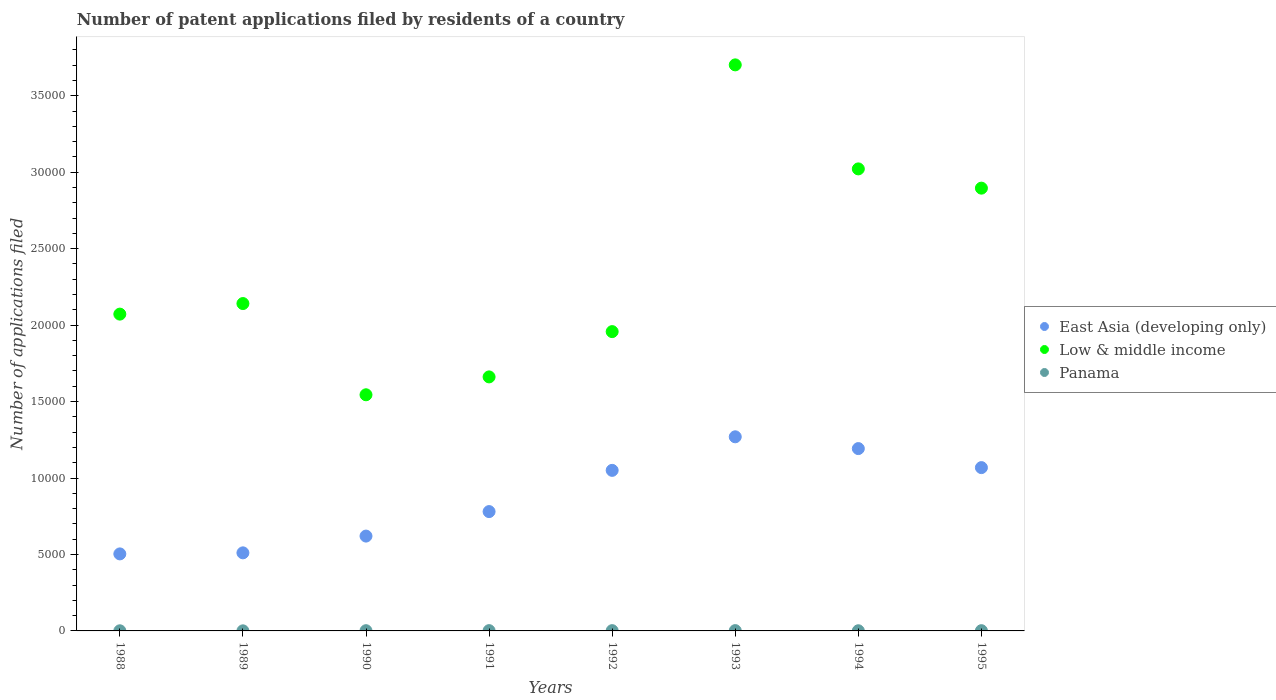What is the number of applications filed in Panama in 1991?
Offer a terse response. 19. Across all years, what is the maximum number of applications filed in Panama?
Offer a very short reply. 20. In which year was the number of applications filed in Panama minimum?
Give a very brief answer. 1989. What is the total number of applications filed in East Asia (developing only) in the graph?
Your answer should be very brief. 6.99e+04. What is the difference between the number of applications filed in East Asia (developing only) in 1988 and that in 1994?
Provide a succinct answer. -6887. What is the difference between the number of applications filed in Panama in 1992 and the number of applications filed in Low & middle income in 1989?
Offer a very short reply. -2.14e+04. What is the average number of applications filed in Low & middle income per year?
Provide a succinct answer. 2.37e+04. In the year 1992, what is the difference between the number of applications filed in East Asia (developing only) and number of applications filed in Low & middle income?
Give a very brief answer. -9074. In how many years, is the number of applications filed in Low & middle income greater than 21000?
Keep it short and to the point. 4. What is the ratio of the number of applications filed in Low & middle income in 1990 to that in 1993?
Your answer should be compact. 0.42. What is the difference between the highest and the lowest number of applications filed in Low & middle income?
Your response must be concise. 2.16e+04. Is the sum of the number of applications filed in Panama in 1988 and 1992 greater than the maximum number of applications filed in East Asia (developing only) across all years?
Provide a succinct answer. No. Is it the case that in every year, the sum of the number of applications filed in East Asia (developing only) and number of applications filed in Panama  is greater than the number of applications filed in Low & middle income?
Your answer should be very brief. No. Does the number of applications filed in East Asia (developing only) monotonically increase over the years?
Ensure brevity in your answer.  No. Is the number of applications filed in East Asia (developing only) strictly greater than the number of applications filed in Low & middle income over the years?
Offer a terse response. No. How many dotlines are there?
Your response must be concise. 3. What is the difference between two consecutive major ticks on the Y-axis?
Your answer should be very brief. 5000. Does the graph contain any zero values?
Provide a short and direct response. No. Does the graph contain grids?
Offer a very short reply. No. Where does the legend appear in the graph?
Keep it short and to the point. Center right. How are the legend labels stacked?
Give a very brief answer. Vertical. What is the title of the graph?
Give a very brief answer. Number of patent applications filed by residents of a country. What is the label or title of the Y-axis?
Your answer should be very brief. Number of applications filed. What is the Number of applications filed in East Asia (developing only) in 1988?
Give a very brief answer. 5037. What is the Number of applications filed of Low & middle income in 1988?
Offer a terse response. 2.07e+04. What is the Number of applications filed of Panama in 1988?
Keep it short and to the point. 9. What is the Number of applications filed of East Asia (developing only) in 1989?
Make the answer very short. 5106. What is the Number of applications filed in Low & middle income in 1989?
Offer a very short reply. 2.14e+04. What is the Number of applications filed of Panama in 1989?
Provide a succinct answer. 6. What is the Number of applications filed in East Asia (developing only) in 1990?
Provide a short and direct response. 6202. What is the Number of applications filed in Low & middle income in 1990?
Give a very brief answer. 1.54e+04. What is the Number of applications filed of Panama in 1990?
Your answer should be very brief. 15. What is the Number of applications filed of East Asia (developing only) in 1991?
Provide a succinct answer. 7804. What is the Number of applications filed in Low & middle income in 1991?
Make the answer very short. 1.66e+04. What is the Number of applications filed in Panama in 1991?
Your answer should be very brief. 19. What is the Number of applications filed in East Asia (developing only) in 1992?
Your answer should be very brief. 1.05e+04. What is the Number of applications filed of Low & middle income in 1992?
Your answer should be compact. 1.96e+04. What is the Number of applications filed in Panama in 1992?
Your response must be concise. 18. What is the Number of applications filed in East Asia (developing only) in 1993?
Provide a succinct answer. 1.27e+04. What is the Number of applications filed in Low & middle income in 1993?
Give a very brief answer. 3.70e+04. What is the Number of applications filed in Panama in 1993?
Give a very brief answer. 20. What is the Number of applications filed of East Asia (developing only) in 1994?
Your answer should be compact. 1.19e+04. What is the Number of applications filed of Low & middle income in 1994?
Give a very brief answer. 3.02e+04. What is the Number of applications filed of East Asia (developing only) in 1995?
Keep it short and to the point. 1.07e+04. What is the Number of applications filed in Low & middle income in 1995?
Offer a very short reply. 2.90e+04. What is the Number of applications filed of Panama in 1995?
Your response must be concise. 16. Across all years, what is the maximum Number of applications filed of East Asia (developing only)?
Your answer should be very brief. 1.27e+04. Across all years, what is the maximum Number of applications filed in Low & middle income?
Your answer should be very brief. 3.70e+04. Across all years, what is the maximum Number of applications filed in Panama?
Offer a very short reply. 20. Across all years, what is the minimum Number of applications filed of East Asia (developing only)?
Ensure brevity in your answer.  5037. Across all years, what is the minimum Number of applications filed in Low & middle income?
Offer a terse response. 1.54e+04. What is the total Number of applications filed of East Asia (developing only) in the graph?
Provide a short and direct response. 6.99e+04. What is the total Number of applications filed of Low & middle income in the graph?
Provide a short and direct response. 1.90e+05. What is the total Number of applications filed of Panama in the graph?
Provide a short and direct response. 114. What is the difference between the Number of applications filed of East Asia (developing only) in 1988 and that in 1989?
Offer a very short reply. -69. What is the difference between the Number of applications filed in Low & middle income in 1988 and that in 1989?
Provide a short and direct response. -691. What is the difference between the Number of applications filed of Panama in 1988 and that in 1989?
Keep it short and to the point. 3. What is the difference between the Number of applications filed in East Asia (developing only) in 1988 and that in 1990?
Offer a terse response. -1165. What is the difference between the Number of applications filed in Low & middle income in 1988 and that in 1990?
Your response must be concise. 5275. What is the difference between the Number of applications filed of Panama in 1988 and that in 1990?
Your answer should be compact. -6. What is the difference between the Number of applications filed in East Asia (developing only) in 1988 and that in 1991?
Give a very brief answer. -2767. What is the difference between the Number of applications filed in Low & middle income in 1988 and that in 1991?
Your response must be concise. 4106. What is the difference between the Number of applications filed in Panama in 1988 and that in 1991?
Offer a terse response. -10. What is the difference between the Number of applications filed in East Asia (developing only) in 1988 and that in 1992?
Your answer should be compact. -5463. What is the difference between the Number of applications filed in Low & middle income in 1988 and that in 1992?
Make the answer very short. 1144. What is the difference between the Number of applications filed in Panama in 1988 and that in 1992?
Your answer should be compact. -9. What is the difference between the Number of applications filed of East Asia (developing only) in 1988 and that in 1993?
Provide a short and direct response. -7658. What is the difference between the Number of applications filed in Low & middle income in 1988 and that in 1993?
Your answer should be compact. -1.63e+04. What is the difference between the Number of applications filed of Panama in 1988 and that in 1993?
Your response must be concise. -11. What is the difference between the Number of applications filed of East Asia (developing only) in 1988 and that in 1994?
Offer a terse response. -6887. What is the difference between the Number of applications filed of Low & middle income in 1988 and that in 1994?
Ensure brevity in your answer.  -9497. What is the difference between the Number of applications filed in Panama in 1988 and that in 1994?
Provide a short and direct response. -2. What is the difference between the Number of applications filed in East Asia (developing only) in 1988 and that in 1995?
Your response must be concise. -5643. What is the difference between the Number of applications filed of Low & middle income in 1988 and that in 1995?
Provide a short and direct response. -8238. What is the difference between the Number of applications filed in Panama in 1988 and that in 1995?
Your answer should be compact. -7. What is the difference between the Number of applications filed of East Asia (developing only) in 1989 and that in 1990?
Offer a terse response. -1096. What is the difference between the Number of applications filed of Low & middle income in 1989 and that in 1990?
Offer a very short reply. 5966. What is the difference between the Number of applications filed of East Asia (developing only) in 1989 and that in 1991?
Make the answer very short. -2698. What is the difference between the Number of applications filed in Low & middle income in 1989 and that in 1991?
Provide a succinct answer. 4797. What is the difference between the Number of applications filed in Panama in 1989 and that in 1991?
Your answer should be very brief. -13. What is the difference between the Number of applications filed in East Asia (developing only) in 1989 and that in 1992?
Give a very brief answer. -5394. What is the difference between the Number of applications filed of Low & middle income in 1989 and that in 1992?
Your answer should be very brief. 1835. What is the difference between the Number of applications filed in East Asia (developing only) in 1989 and that in 1993?
Offer a very short reply. -7589. What is the difference between the Number of applications filed in Low & middle income in 1989 and that in 1993?
Your response must be concise. -1.56e+04. What is the difference between the Number of applications filed in Panama in 1989 and that in 1993?
Your answer should be compact. -14. What is the difference between the Number of applications filed in East Asia (developing only) in 1989 and that in 1994?
Offer a terse response. -6818. What is the difference between the Number of applications filed of Low & middle income in 1989 and that in 1994?
Offer a terse response. -8806. What is the difference between the Number of applications filed in Panama in 1989 and that in 1994?
Make the answer very short. -5. What is the difference between the Number of applications filed of East Asia (developing only) in 1989 and that in 1995?
Offer a terse response. -5574. What is the difference between the Number of applications filed in Low & middle income in 1989 and that in 1995?
Your answer should be compact. -7547. What is the difference between the Number of applications filed of Panama in 1989 and that in 1995?
Ensure brevity in your answer.  -10. What is the difference between the Number of applications filed in East Asia (developing only) in 1990 and that in 1991?
Give a very brief answer. -1602. What is the difference between the Number of applications filed of Low & middle income in 1990 and that in 1991?
Ensure brevity in your answer.  -1169. What is the difference between the Number of applications filed of East Asia (developing only) in 1990 and that in 1992?
Your response must be concise. -4298. What is the difference between the Number of applications filed of Low & middle income in 1990 and that in 1992?
Offer a terse response. -4131. What is the difference between the Number of applications filed of East Asia (developing only) in 1990 and that in 1993?
Give a very brief answer. -6493. What is the difference between the Number of applications filed in Low & middle income in 1990 and that in 1993?
Offer a very short reply. -2.16e+04. What is the difference between the Number of applications filed in East Asia (developing only) in 1990 and that in 1994?
Provide a succinct answer. -5722. What is the difference between the Number of applications filed in Low & middle income in 1990 and that in 1994?
Keep it short and to the point. -1.48e+04. What is the difference between the Number of applications filed in East Asia (developing only) in 1990 and that in 1995?
Offer a terse response. -4478. What is the difference between the Number of applications filed of Low & middle income in 1990 and that in 1995?
Your answer should be compact. -1.35e+04. What is the difference between the Number of applications filed of Panama in 1990 and that in 1995?
Offer a terse response. -1. What is the difference between the Number of applications filed in East Asia (developing only) in 1991 and that in 1992?
Make the answer very short. -2696. What is the difference between the Number of applications filed in Low & middle income in 1991 and that in 1992?
Keep it short and to the point. -2962. What is the difference between the Number of applications filed in Panama in 1991 and that in 1992?
Your answer should be very brief. 1. What is the difference between the Number of applications filed of East Asia (developing only) in 1991 and that in 1993?
Provide a short and direct response. -4891. What is the difference between the Number of applications filed of Low & middle income in 1991 and that in 1993?
Offer a terse response. -2.04e+04. What is the difference between the Number of applications filed in East Asia (developing only) in 1991 and that in 1994?
Your response must be concise. -4120. What is the difference between the Number of applications filed in Low & middle income in 1991 and that in 1994?
Provide a short and direct response. -1.36e+04. What is the difference between the Number of applications filed in East Asia (developing only) in 1991 and that in 1995?
Keep it short and to the point. -2876. What is the difference between the Number of applications filed of Low & middle income in 1991 and that in 1995?
Provide a short and direct response. -1.23e+04. What is the difference between the Number of applications filed of East Asia (developing only) in 1992 and that in 1993?
Your answer should be very brief. -2195. What is the difference between the Number of applications filed in Low & middle income in 1992 and that in 1993?
Make the answer very short. -1.74e+04. What is the difference between the Number of applications filed of Panama in 1992 and that in 1993?
Give a very brief answer. -2. What is the difference between the Number of applications filed in East Asia (developing only) in 1992 and that in 1994?
Provide a succinct answer. -1424. What is the difference between the Number of applications filed of Low & middle income in 1992 and that in 1994?
Ensure brevity in your answer.  -1.06e+04. What is the difference between the Number of applications filed in Panama in 1992 and that in 1994?
Provide a short and direct response. 7. What is the difference between the Number of applications filed in East Asia (developing only) in 1992 and that in 1995?
Make the answer very short. -180. What is the difference between the Number of applications filed of Low & middle income in 1992 and that in 1995?
Provide a succinct answer. -9382. What is the difference between the Number of applications filed of Panama in 1992 and that in 1995?
Provide a short and direct response. 2. What is the difference between the Number of applications filed in East Asia (developing only) in 1993 and that in 1994?
Ensure brevity in your answer.  771. What is the difference between the Number of applications filed of Low & middle income in 1993 and that in 1994?
Make the answer very short. 6803. What is the difference between the Number of applications filed of East Asia (developing only) in 1993 and that in 1995?
Make the answer very short. 2015. What is the difference between the Number of applications filed of Low & middle income in 1993 and that in 1995?
Ensure brevity in your answer.  8062. What is the difference between the Number of applications filed in East Asia (developing only) in 1994 and that in 1995?
Offer a very short reply. 1244. What is the difference between the Number of applications filed of Low & middle income in 1994 and that in 1995?
Provide a succinct answer. 1259. What is the difference between the Number of applications filed of East Asia (developing only) in 1988 and the Number of applications filed of Low & middle income in 1989?
Offer a terse response. -1.64e+04. What is the difference between the Number of applications filed of East Asia (developing only) in 1988 and the Number of applications filed of Panama in 1989?
Provide a short and direct response. 5031. What is the difference between the Number of applications filed of Low & middle income in 1988 and the Number of applications filed of Panama in 1989?
Your answer should be compact. 2.07e+04. What is the difference between the Number of applications filed of East Asia (developing only) in 1988 and the Number of applications filed of Low & middle income in 1990?
Provide a succinct answer. -1.04e+04. What is the difference between the Number of applications filed in East Asia (developing only) in 1988 and the Number of applications filed in Panama in 1990?
Ensure brevity in your answer.  5022. What is the difference between the Number of applications filed in Low & middle income in 1988 and the Number of applications filed in Panama in 1990?
Your response must be concise. 2.07e+04. What is the difference between the Number of applications filed of East Asia (developing only) in 1988 and the Number of applications filed of Low & middle income in 1991?
Offer a terse response. -1.16e+04. What is the difference between the Number of applications filed in East Asia (developing only) in 1988 and the Number of applications filed in Panama in 1991?
Your response must be concise. 5018. What is the difference between the Number of applications filed in Low & middle income in 1988 and the Number of applications filed in Panama in 1991?
Offer a very short reply. 2.07e+04. What is the difference between the Number of applications filed in East Asia (developing only) in 1988 and the Number of applications filed in Low & middle income in 1992?
Offer a terse response. -1.45e+04. What is the difference between the Number of applications filed of East Asia (developing only) in 1988 and the Number of applications filed of Panama in 1992?
Ensure brevity in your answer.  5019. What is the difference between the Number of applications filed in Low & middle income in 1988 and the Number of applications filed in Panama in 1992?
Your answer should be very brief. 2.07e+04. What is the difference between the Number of applications filed of East Asia (developing only) in 1988 and the Number of applications filed of Low & middle income in 1993?
Your response must be concise. -3.20e+04. What is the difference between the Number of applications filed of East Asia (developing only) in 1988 and the Number of applications filed of Panama in 1993?
Offer a terse response. 5017. What is the difference between the Number of applications filed in Low & middle income in 1988 and the Number of applications filed in Panama in 1993?
Provide a succinct answer. 2.07e+04. What is the difference between the Number of applications filed of East Asia (developing only) in 1988 and the Number of applications filed of Low & middle income in 1994?
Your answer should be very brief. -2.52e+04. What is the difference between the Number of applications filed in East Asia (developing only) in 1988 and the Number of applications filed in Panama in 1994?
Keep it short and to the point. 5026. What is the difference between the Number of applications filed in Low & middle income in 1988 and the Number of applications filed in Panama in 1994?
Provide a succinct answer. 2.07e+04. What is the difference between the Number of applications filed in East Asia (developing only) in 1988 and the Number of applications filed in Low & middle income in 1995?
Provide a succinct answer. -2.39e+04. What is the difference between the Number of applications filed of East Asia (developing only) in 1988 and the Number of applications filed of Panama in 1995?
Provide a succinct answer. 5021. What is the difference between the Number of applications filed in Low & middle income in 1988 and the Number of applications filed in Panama in 1995?
Offer a terse response. 2.07e+04. What is the difference between the Number of applications filed of East Asia (developing only) in 1989 and the Number of applications filed of Low & middle income in 1990?
Offer a terse response. -1.03e+04. What is the difference between the Number of applications filed in East Asia (developing only) in 1989 and the Number of applications filed in Panama in 1990?
Offer a terse response. 5091. What is the difference between the Number of applications filed in Low & middle income in 1989 and the Number of applications filed in Panama in 1990?
Provide a succinct answer. 2.14e+04. What is the difference between the Number of applications filed of East Asia (developing only) in 1989 and the Number of applications filed of Low & middle income in 1991?
Ensure brevity in your answer.  -1.15e+04. What is the difference between the Number of applications filed in East Asia (developing only) in 1989 and the Number of applications filed in Panama in 1991?
Make the answer very short. 5087. What is the difference between the Number of applications filed of Low & middle income in 1989 and the Number of applications filed of Panama in 1991?
Offer a very short reply. 2.14e+04. What is the difference between the Number of applications filed in East Asia (developing only) in 1989 and the Number of applications filed in Low & middle income in 1992?
Your answer should be compact. -1.45e+04. What is the difference between the Number of applications filed of East Asia (developing only) in 1989 and the Number of applications filed of Panama in 1992?
Offer a very short reply. 5088. What is the difference between the Number of applications filed of Low & middle income in 1989 and the Number of applications filed of Panama in 1992?
Your answer should be compact. 2.14e+04. What is the difference between the Number of applications filed of East Asia (developing only) in 1989 and the Number of applications filed of Low & middle income in 1993?
Provide a succinct answer. -3.19e+04. What is the difference between the Number of applications filed of East Asia (developing only) in 1989 and the Number of applications filed of Panama in 1993?
Provide a succinct answer. 5086. What is the difference between the Number of applications filed of Low & middle income in 1989 and the Number of applications filed of Panama in 1993?
Give a very brief answer. 2.14e+04. What is the difference between the Number of applications filed in East Asia (developing only) in 1989 and the Number of applications filed in Low & middle income in 1994?
Offer a very short reply. -2.51e+04. What is the difference between the Number of applications filed of East Asia (developing only) in 1989 and the Number of applications filed of Panama in 1994?
Give a very brief answer. 5095. What is the difference between the Number of applications filed in Low & middle income in 1989 and the Number of applications filed in Panama in 1994?
Ensure brevity in your answer.  2.14e+04. What is the difference between the Number of applications filed in East Asia (developing only) in 1989 and the Number of applications filed in Low & middle income in 1995?
Offer a very short reply. -2.38e+04. What is the difference between the Number of applications filed in East Asia (developing only) in 1989 and the Number of applications filed in Panama in 1995?
Your answer should be very brief. 5090. What is the difference between the Number of applications filed in Low & middle income in 1989 and the Number of applications filed in Panama in 1995?
Your answer should be very brief. 2.14e+04. What is the difference between the Number of applications filed of East Asia (developing only) in 1990 and the Number of applications filed of Low & middle income in 1991?
Your response must be concise. -1.04e+04. What is the difference between the Number of applications filed in East Asia (developing only) in 1990 and the Number of applications filed in Panama in 1991?
Make the answer very short. 6183. What is the difference between the Number of applications filed in Low & middle income in 1990 and the Number of applications filed in Panama in 1991?
Offer a very short reply. 1.54e+04. What is the difference between the Number of applications filed of East Asia (developing only) in 1990 and the Number of applications filed of Low & middle income in 1992?
Your answer should be very brief. -1.34e+04. What is the difference between the Number of applications filed of East Asia (developing only) in 1990 and the Number of applications filed of Panama in 1992?
Offer a very short reply. 6184. What is the difference between the Number of applications filed in Low & middle income in 1990 and the Number of applications filed in Panama in 1992?
Your answer should be very brief. 1.54e+04. What is the difference between the Number of applications filed in East Asia (developing only) in 1990 and the Number of applications filed in Low & middle income in 1993?
Your answer should be compact. -3.08e+04. What is the difference between the Number of applications filed in East Asia (developing only) in 1990 and the Number of applications filed in Panama in 1993?
Your response must be concise. 6182. What is the difference between the Number of applications filed in Low & middle income in 1990 and the Number of applications filed in Panama in 1993?
Give a very brief answer. 1.54e+04. What is the difference between the Number of applications filed in East Asia (developing only) in 1990 and the Number of applications filed in Low & middle income in 1994?
Provide a short and direct response. -2.40e+04. What is the difference between the Number of applications filed in East Asia (developing only) in 1990 and the Number of applications filed in Panama in 1994?
Provide a succinct answer. 6191. What is the difference between the Number of applications filed of Low & middle income in 1990 and the Number of applications filed of Panama in 1994?
Offer a very short reply. 1.54e+04. What is the difference between the Number of applications filed of East Asia (developing only) in 1990 and the Number of applications filed of Low & middle income in 1995?
Keep it short and to the point. -2.28e+04. What is the difference between the Number of applications filed of East Asia (developing only) in 1990 and the Number of applications filed of Panama in 1995?
Give a very brief answer. 6186. What is the difference between the Number of applications filed of Low & middle income in 1990 and the Number of applications filed of Panama in 1995?
Ensure brevity in your answer.  1.54e+04. What is the difference between the Number of applications filed in East Asia (developing only) in 1991 and the Number of applications filed in Low & middle income in 1992?
Your answer should be compact. -1.18e+04. What is the difference between the Number of applications filed of East Asia (developing only) in 1991 and the Number of applications filed of Panama in 1992?
Ensure brevity in your answer.  7786. What is the difference between the Number of applications filed of Low & middle income in 1991 and the Number of applications filed of Panama in 1992?
Keep it short and to the point. 1.66e+04. What is the difference between the Number of applications filed of East Asia (developing only) in 1991 and the Number of applications filed of Low & middle income in 1993?
Your answer should be very brief. -2.92e+04. What is the difference between the Number of applications filed of East Asia (developing only) in 1991 and the Number of applications filed of Panama in 1993?
Offer a terse response. 7784. What is the difference between the Number of applications filed of Low & middle income in 1991 and the Number of applications filed of Panama in 1993?
Keep it short and to the point. 1.66e+04. What is the difference between the Number of applications filed in East Asia (developing only) in 1991 and the Number of applications filed in Low & middle income in 1994?
Your answer should be compact. -2.24e+04. What is the difference between the Number of applications filed in East Asia (developing only) in 1991 and the Number of applications filed in Panama in 1994?
Provide a succinct answer. 7793. What is the difference between the Number of applications filed of Low & middle income in 1991 and the Number of applications filed of Panama in 1994?
Keep it short and to the point. 1.66e+04. What is the difference between the Number of applications filed of East Asia (developing only) in 1991 and the Number of applications filed of Low & middle income in 1995?
Your answer should be very brief. -2.12e+04. What is the difference between the Number of applications filed of East Asia (developing only) in 1991 and the Number of applications filed of Panama in 1995?
Offer a terse response. 7788. What is the difference between the Number of applications filed in Low & middle income in 1991 and the Number of applications filed in Panama in 1995?
Offer a terse response. 1.66e+04. What is the difference between the Number of applications filed in East Asia (developing only) in 1992 and the Number of applications filed in Low & middle income in 1993?
Provide a succinct answer. -2.65e+04. What is the difference between the Number of applications filed in East Asia (developing only) in 1992 and the Number of applications filed in Panama in 1993?
Offer a terse response. 1.05e+04. What is the difference between the Number of applications filed of Low & middle income in 1992 and the Number of applications filed of Panama in 1993?
Offer a very short reply. 1.96e+04. What is the difference between the Number of applications filed in East Asia (developing only) in 1992 and the Number of applications filed in Low & middle income in 1994?
Make the answer very short. -1.97e+04. What is the difference between the Number of applications filed in East Asia (developing only) in 1992 and the Number of applications filed in Panama in 1994?
Keep it short and to the point. 1.05e+04. What is the difference between the Number of applications filed of Low & middle income in 1992 and the Number of applications filed of Panama in 1994?
Your response must be concise. 1.96e+04. What is the difference between the Number of applications filed of East Asia (developing only) in 1992 and the Number of applications filed of Low & middle income in 1995?
Keep it short and to the point. -1.85e+04. What is the difference between the Number of applications filed in East Asia (developing only) in 1992 and the Number of applications filed in Panama in 1995?
Your answer should be compact. 1.05e+04. What is the difference between the Number of applications filed of Low & middle income in 1992 and the Number of applications filed of Panama in 1995?
Ensure brevity in your answer.  1.96e+04. What is the difference between the Number of applications filed in East Asia (developing only) in 1993 and the Number of applications filed in Low & middle income in 1994?
Make the answer very short. -1.75e+04. What is the difference between the Number of applications filed in East Asia (developing only) in 1993 and the Number of applications filed in Panama in 1994?
Ensure brevity in your answer.  1.27e+04. What is the difference between the Number of applications filed in Low & middle income in 1993 and the Number of applications filed in Panama in 1994?
Your answer should be very brief. 3.70e+04. What is the difference between the Number of applications filed of East Asia (developing only) in 1993 and the Number of applications filed of Low & middle income in 1995?
Provide a succinct answer. -1.63e+04. What is the difference between the Number of applications filed in East Asia (developing only) in 1993 and the Number of applications filed in Panama in 1995?
Provide a short and direct response. 1.27e+04. What is the difference between the Number of applications filed of Low & middle income in 1993 and the Number of applications filed of Panama in 1995?
Give a very brief answer. 3.70e+04. What is the difference between the Number of applications filed in East Asia (developing only) in 1994 and the Number of applications filed in Low & middle income in 1995?
Offer a very short reply. -1.70e+04. What is the difference between the Number of applications filed of East Asia (developing only) in 1994 and the Number of applications filed of Panama in 1995?
Your answer should be compact. 1.19e+04. What is the difference between the Number of applications filed of Low & middle income in 1994 and the Number of applications filed of Panama in 1995?
Your response must be concise. 3.02e+04. What is the average Number of applications filed of East Asia (developing only) per year?
Provide a short and direct response. 8743.5. What is the average Number of applications filed of Low & middle income per year?
Provide a succinct answer. 2.37e+04. What is the average Number of applications filed of Panama per year?
Make the answer very short. 14.25. In the year 1988, what is the difference between the Number of applications filed in East Asia (developing only) and Number of applications filed in Low & middle income?
Provide a short and direct response. -1.57e+04. In the year 1988, what is the difference between the Number of applications filed in East Asia (developing only) and Number of applications filed in Panama?
Provide a succinct answer. 5028. In the year 1988, what is the difference between the Number of applications filed of Low & middle income and Number of applications filed of Panama?
Offer a terse response. 2.07e+04. In the year 1989, what is the difference between the Number of applications filed in East Asia (developing only) and Number of applications filed in Low & middle income?
Provide a succinct answer. -1.63e+04. In the year 1989, what is the difference between the Number of applications filed in East Asia (developing only) and Number of applications filed in Panama?
Keep it short and to the point. 5100. In the year 1989, what is the difference between the Number of applications filed of Low & middle income and Number of applications filed of Panama?
Provide a short and direct response. 2.14e+04. In the year 1990, what is the difference between the Number of applications filed of East Asia (developing only) and Number of applications filed of Low & middle income?
Provide a short and direct response. -9241. In the year 1990, what is the difference between the Number of applications filed of East Asia (developing only) and Number of applications filed of Panama?
Make the answer very short. 6187. In the year 1990, what is the difference between the Number of applications filed of Low & middle income and Number of applications filed of Panama?
Offer a terse response. 1.54e+04. In the year 1991, what is the difference between the Number of applications filed of East Asia (developing only) and Number of applications filed of Low & middle income?
Ensure brevity in your answer.  -8808. In the year 1991, what is the difference between the Number of applications filed in East Asia (developing only) and Number of applications filed in Panama?
Your answer should be compact. 7785. In the year 1991, what is the difference between the Number of applications filed of Low & middle income and Number of applications filed of Panama?
Provide a short and direct response. 1.66e+04. In the year 1992, what is the difference between the Number of applications filed of East Asia (developing only) and Number of applications filed of Low & middle income?
Ensure brevity in your answer.  -9074. In the year 1992, what is the difference between the Number of applications filed of East Asia (developing only) and Number of applications filed of Panama?
Your response must be concise. 1.05e+04. In the year 1992, what is the difference between the Number of applications filed in Low & middle income and Number of applications filed in Panama?
Ensure brevity in your answer.  1.96e+04. In the year 1993, what is the difference between the Number of applications filed of East Asia (developing only) and Number of applications filed of Low & middle income?
Your answer should be compact. -2.43e+04. In the year 1993, what is the difference between the Number of applications filed of East Asia (developing only) and Number of applications filed of Panama?
Provide a succinct answer. 1.27e+04. In the year 1993, what is the difference between the Number of applications filed of Low & middle income and Number of applications filed of Panama?
Your answer should be very brief. 3.70e+04. In the year 1994, what is the difference between the Number of applications filed of East Asia (developing only) and Number of applications filed of Low & middle income?
Make the answer very short. -1.83e+04. In the year 1994, what is the difference between the Number of applications filed in East Asia (developing only) and Number of applications filed in Panama?
Provide a short and direct response. 1.19e+04. In the year 1994, what is the difference between the Number of applications filed in Low & middle income and Number of applications filed in Panama?
Keep it short and to the point. 3.02e+04. In the year 1995, what is the difference between the Number of applications filed in East Asia (developing only) and Number of applications filed in Low & middle income?
Your answer should be compact. -1.83e+04. In the year 1995, what is the difference between the Number of applications filed of East Asia (developing only) and Number of applications filed of Panama?
Offer a very short reply. 1.07e+04. In the year 1995, what is the difference between the Number of applications filed of Low & middle income and Number of applications filed of Panama?
Your answer should be very brief. 2.89e+04. What is the ratio of the Number of applications filed of East Asia (developing only) in 1988 to that in 1989?
Provide a short and direct response. 0.99. What is the ratio of the Number of applications filed in Panama in 1988 to that in 1989?
Your answer should be very brief. 1.5. What is the ratio of the Number of applications filed in East Asia (developing only) in 1988 to that in 1990?
Give a very brief answer. 0.81. What is the ratio of the Number of applications filed of Low & middle income in 1988 to that in 1990?
Ensure brevity in your answer.  1.34. What is the ratio of the Number of applications filed of East Asia (developing only) in 1988 to that in 1991?
Your answer should be compact. 0.65. What is the ratio of the Number of applications filed in Low & middle income in 1988 to that in 1991?
Ensure brevity in your answer.  1.25. What is the ratio of the Number of applications filed in Panama in 1988 to that in 1991?
Your answer should be very brief. 0.47. What is the ratio of the Number of applications filed of East Asia (developing only) in 1988 to that in 1992?
Offer a very short reply. 0.48. What is the ratio of the Number of applications filed of Low & middle income in 1988 to that in 1992?
Make the answer very short. 1.06. What is the ratio of the Number of applications filed in Panama in 1988 to that in 1992?
Your response must be concise. 0.5. What is the ratio of the Number of applications filed in East Asia (developing only) in 1988 to that in 1993?
Your answer should be very brief. 0.4. What is the ratio of the Number of applications filed of Low & middle income in 1988 to that in 1993?
Ensure brevity in your answer.  0.56. What is the ratio of the Number of applications filed in Panama in 1988 to that in 1993?
Keep it short and to the point. 0.45. What is the ratio of the Number of applications filed in East Asia (developing only) in 1988 to that in 1994?
Offer a terse response. 0.42. What is the ratio of the Number of applications filed of Low & middle income in 1988 to that in 1994?
Your answer should be very brief. 0.69. What is the ratio of the Number of applications filed of Panama in 1988 to that in 1994?
Offer a terse response. 0.82. What is the ratio of the Number of applications filed in East Asia (developing only) in 1988 to that in 1995?
Your answer should be very brief. 0.47. What is the ratio of the Number of applications filed of Low & middle income in 1988 to that in 1995?
Offer a very short reply. 0.72. What is the ratio of the Number of applications filed of Panama in 1988 to that in 1995?
Your answer should be very brief. 0.56. What is the ratio of the Number of applications filed in East Asia (developing only) in 1989 to that in 1990?
Your response must be concise. 0.82. What is the ratio of the Number of applications filed of Low & middle income in 1989 to that in 1990?
Your answer should be very brief. 1.39. What is the ratio of the Number of applications filed in Panama in 1989 to that in 1990?
Your response must be concise. 0.4. What is the ratio of the Number of applications filed of East Asia (developing only) in 1989 to that in 1991?
Make the answer very short. 0.65. What is the ratio of the Number of applications filed in Low & middle income in 1989 to that in 1991?
Your response must be concise. 1.29. What is the ratio of the Number of applications filed in Panama in 1989 to that in 1991?
Offer a very short reply. 0.32. What is the ratio of the Number of applications filed of East Asia (developing only) in 1989 to that in 1992?
Your answer should be compact. 0.49. What is the ratio of the Number of applications filed in Low & middle income in 1989 to that in 1992?
Give a very brief answer. 1.09. What is the ratio of the Number of applications filed in East Asia (developing only) in 1989 to that in 1993?
Keep it short and to the point. 0.4. What is the ratio of the Number of applications filed of Low & middle income in 1989 to that in 1993?
Offer a terse response. 0.58. What is the ratio of the Number of applications filed of East Asia (developing only) in 1989 to that in 1994?
Your answer should be very brief. 0.43. What is the ratio of the Number of applications filed in Low & middle income in 1989 to that in 1994?
Your answer should be very brief. 0.71. What is the ratio of the Number of applications filed in Panama in 1989 to that in 1994?
Keep it short and to the point. 0.55. What is the ratio of the Number of applications filed in East Asia (developing only) in 1989 to that in 1995?
Keep it short and to the point. 0.48. What is the ratio of the Number of applications filed in Low & middle income in 1989 to that in 1995?
Provide a short and direct response. 0.74. What is the ratio of the Number of applications filed of Panama in 1989 to that in 1995?
Ensure brevity in your answer.  0.38. What is the ratio of the Number of applications filed of East Asia (developing only) in 1990 to that in 1991?
Ensure brevity in your answer.  0.79. What is the ratio of the Number of applications filed of Low & middle income in 1990 to that in 1991?
Your answer should be very brief. 0.93. What is the ratio of the Number of applications filed in Panama in 1990 to that in 1991?
Keep it short and to the point. 0.79. What is the ratio of the Number of applications filed in East Asia (developing only) in 1990 to that in 1992?
Provide a short and direct response. 0.59. What is the ratio of the Number of applications filed in Low & middle income in 1990 to that in 1992?
Offer a very short reply. 0.79. What is the ratio of the Number of applications filed in East Asia (developing only) in 1990 to that in 1993?
Ensure brevity in your answer.  0.49. What is the ratio of the Number of applications filed in Low & middle income in 1990 to that in 1993?
Make the answer very short. 0.42. What is the ratio of the Number of applications filed in East Asia (developing only) in 1990 to that in 1994?
Provide a succinct answer. 0.52. What is the ratio of the Number of applications filed in Low & middle income in 1990 to that in 1994?
Offer a terse response. 0.51. What is the ratio of the Number of applications filed of Panama in 1990 to that in 1994?
Your response must be concise. 1.36. What is the ratio of the Number of applications filed in East Asia (developing only) in 1990 to that in 1995?
Ensure brevity in your answer.  0.58. What is the ratio of the Number of applications filed in Low & middle income in 1990 to that in 1995?
Provide a short and direct response. 0.53. What is the ratio of the Number of applications filed in Panama in 1990 to that in 1995?
Your answer should be compact. 0.94. What is the ratio of the Number of applications filed of East Asia (developing only) in 1991 to that in 1992?
Your answer should be very brief. 0.74. What is the ratio of the Number of applications filed in Low & middle income in 1991 to that in 1992?
Offer a very short reply. 0.85. What is the ratio of the Number of applications filed of Panama in 1991 to that in 1992?
Ensure brevity in your answer.  1.06. What is the ratio of the Number of applications filed of East Asia (developing only) in 1991 to that in 1993?
Your answer should be very brief. 0.61. What is the ratio of the Number of applications filed of Low & middle income in 1991 to that in 1993?
Keep it short and to the point. 0.45. What is the ratio of the Number of applications filed in Panama in 1991 to that in 1993?
Offer a very short reply. 0.95. What is the ratio of the Number of applications filed of East Asia (developing only) in 1991 to that in 1994?
Ensure brevity in your answer.  0.65. What is the ratio of the Number of applications filed of Low & middle income in 1991 to that in 1994?
Provide a succinct answer. 0.55. What is the ratio of the Number of applications filed in Panama in 1991 to that in 1994?
Give a very brief answer. 1.73. What is the ratio of the Number of applications filed in East Asia (developing only) in 1991 to that in 1995?
Your answer should be compact. 0.73. What is the ratio of the Number of applications filed in Low & middle income in 1991 to that in 1995?
Keep it short and to the point. 0.57. What is the ratio of the Number of applications filed in Panama in 1991 to that in 1995?
Give a very brief answer. 1.19. What is the ratio of the Number of applications filed in East Asia (developing only) in 1992 to that in 1993?
Provide a succinct answer. 0.83. What is the ratio of the Number of applications filed of Low & middle income in 1992 to that in 1993?
Keep it short and to the point. 0.53. What is the ratio of the Number of applications filed of East Asia (developing only) in 1992 to that in 1994?
Give a very brief answer. 0.88. What is the ratio of the Number of applications filed of Low & middle income in 1992 to that in 1994?
Give a very brief answer. 0.65. What is the ratio of the Number of applications filed in Panama in 1992 to that in 1994?
Offer a very short reply. 1.64. What is the ratio of the Number of applications filed of East Asia (developing only) in 1992 to that in 1995?
Your answer should be compact. 0.98. What is the ratio of the Number of applications filed in Low & middle income in 1992 to that in 1995?
Provide a succinct answer. 0.68. What is the ratio of the Number of applications filed in Panama in 1992 to that in 1995?
Your response must be concise. 1.12. What is the ratio of the Number of applications filed in East Asia (developing only) in 1993 to that in 1994?
Keep it short and to the point. 1.06. What is the ratio of the Number of applications filed in Low & middle income in 1993 to that in 1994?
Your answer should be very brief. 1.23. What is the ratio of the Number of applications filed of Panama in 1993 to that in 1994?
Your answer should be very brief. 1.82. What is the ratio of the Number of applications filed in East Asia (developing only) in 1993 to that in 1995?
Your answer should be compact. 1.19. What is the ratio of the Number of applications filed of Low & middle income in 1993 to that in 1995?
Your response must be concise. 1.28. What is the ratio of the Number of applications filed in Panama in 1993 to that in 1995?
Your response must be concise. 1.25. What is the ratio of the Number of applications filed of East Asia (developing only) in 1994 to that in 1995?
Your answer should be very brief. 1.12. What is the ratio of the Number of applications filed of Low & middle income in 1994 to that in 1995?
Your response must be concise. 1.04. What is the ratio of the Number of applications filed of Panama in 1994 to that in 1995?
Your answer should be compact. 0.69. What is the difference between the highest and the second highest Number of applications filed in East Asia (developing only)?
Your answer should be compact. 771. What is the difference between the highest and the second highest Number of applications filed of Low & middle income?
Your answer should be very brief. 6803. What is the difference between the highest and the lowest Number of applications filed in East Asia (developing only)?
Keep it short and to the point. 7658. What is the difference between the highest and the lowest Number of applications filed of Low & middle income?
Offer a terse response. 2.16e+04. 